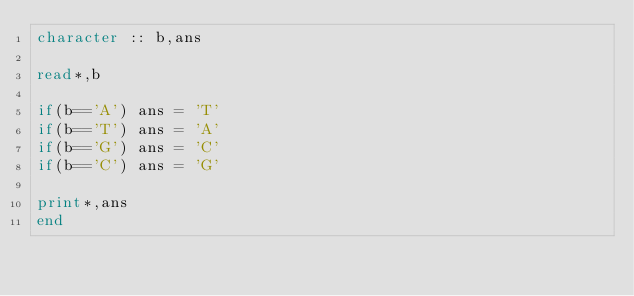Convert code to text. <code><loc_0><loc_0><loc_500><loc_500><_FORTRAN_>character :: b,ans

read*,b

if(b=='A') ans = 'T'
if(b=='T') ans = 'A'
if(b=='G') ans = 'C'
if(b=='C') ans = 'G'

print*,ans
end</code> 